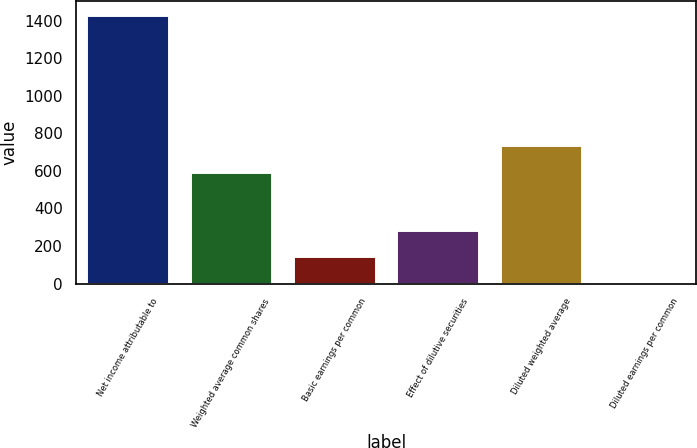Convert chart to OTSL. <chart><loc_0><loc_0><loc_500><loc_500><bar_chart><fcel>Net income attributable to<fcel>Weighted average common shares<fcel>Basic earnings per common<fcel>Effect of dilutive securities<fcel>Diluted weighted average<fcel>Diluted earnings per common<nl><fcel>1430<fcel>595<fcel>145.15<fcel>287.91<fcel>737.76<fcel>2.39<nl></chart> 